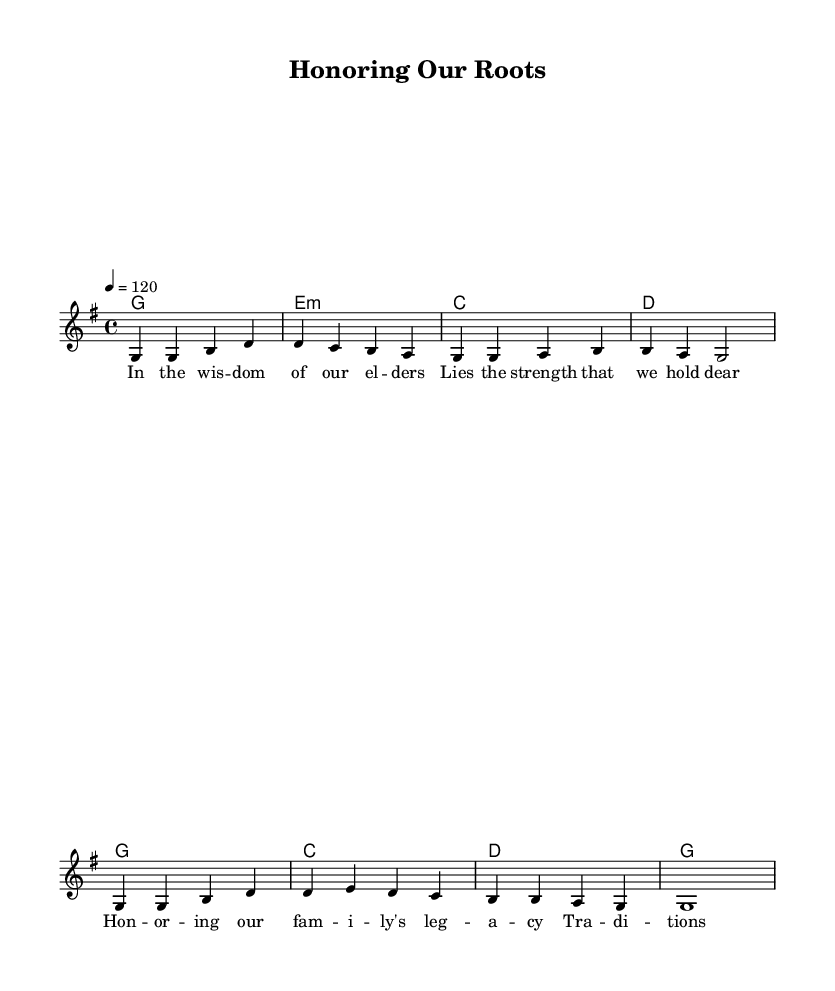What is the key signature of this music? The key signature is G major, which has one sharp (F#).
Answer: G major What is the time signature of this music? The time signature is 4/4, indicating four beats per measure.
Answer: 4/4 What is the tempo marking in this sheet music? The tempo marking indicates the music should be played at a speed of 120 beats per minute.
Answer: 120 How many measures are in the melody section? There are eight measures present in the melody, as counted from the beginning to the end of the melody notation.
Answer: 8 What is the first word of the lyrics? The first word of the lyrics is "In", which appears in the first measure of the lyric section.
Answer: In Which chord is used at the beginning of the harmonies? The first chord in the harmonies is G major, the tonal center of the piece.
Answer: G What theme is emphasized in the lyrics of this piece? The lyrics emphasize family values and the legacy of elders, highlighting familial respect and tradition.
Answer: Family values 